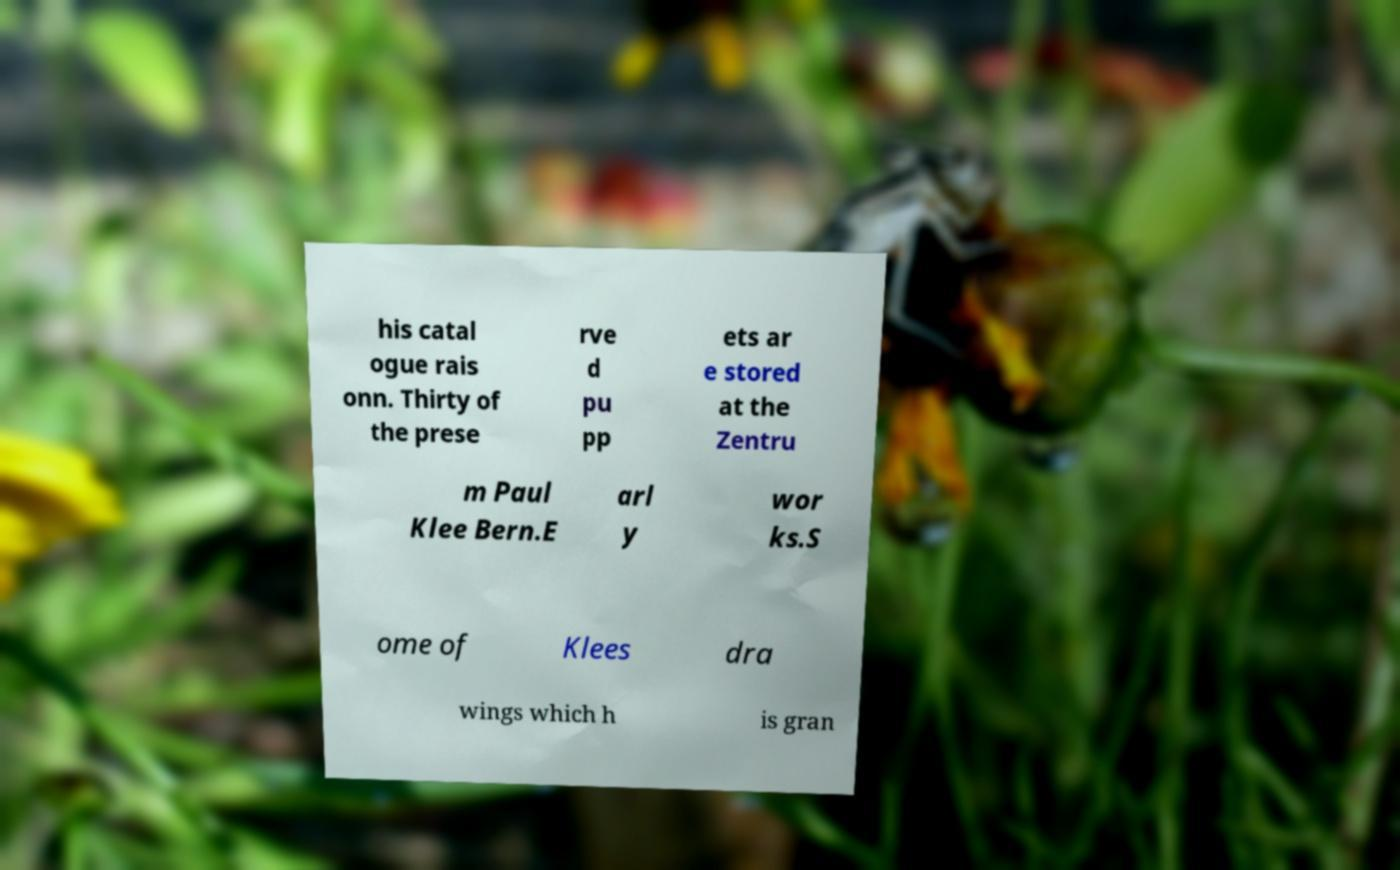For documentation purposes, I need the text within this image transcribed. Could you provide that? his catal ogue rais onn. Thirty of the prese rve d pu pp ets ar e stored at the Zentru m Paul Klee Bern.E arl y wor ks.S ome of Klees dra wings which h is gran 